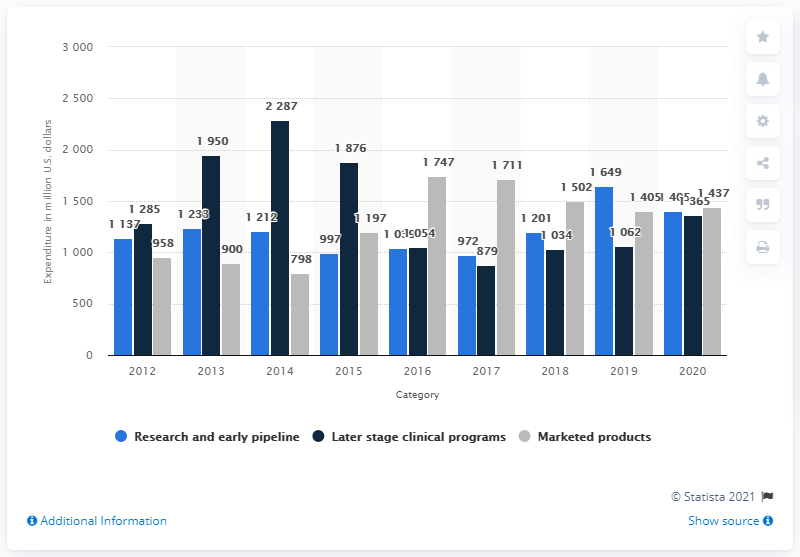Mention a couple of crucial points in this snapshot. According to the information provided, approximately 1365 of Amgen's research and development expenses were allocated towards later-stage clinical programs. 